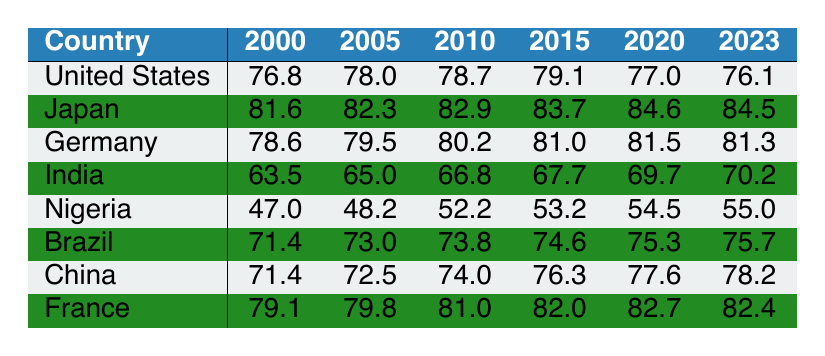What was the life expectancy of Japan in 2010? According to the table, the life expectancy of Japan in 2010 is directly listed as 82.9 years.
Answer: 82.9 Which country had the lowest life expectancy in 2000? Looking at the table, Nigeria had the lowest life expectancy in 2000, recorded at 47.0 years.
Answer: Nigeria What is the difference in life expectancy for China between 2000 and 2023? For China, the life expectancy in 2000 was 71.4 years and in 2023 it is 78.2 years. The difference is 78.2 - 71.4 = 6.8 years.
Answer: 6.8 In which year did Brazil have a life expectancy exceeding 75 years for the first time? By examining the table, Brazil first exceeded a life expectancy of 75 years in 2020, where it is recorded at 75.3 years.
Answer: 2020 Is it true that Germany's life expectancy has decreased from 2015 to 2023? From the table, the life expectancy for Germany in 2015 was 81.0 years, and in 2023 it is 81.3 years, indicating an increase, not a decrease.
Answer: No What is the average life expectancy of India from 2000 to 2023? To calculate the average life expectancy of India from 2000 to 2023, first sum the values: (63.5 + 65.0 + 66.8 + 67.7 + 69.7 + 70.2) = 402.9. Then divide by 6 (the number of years) to get the average: 402.9 / 6 = 67.15 years.
Answer: 67.15 Which country showed the highest life expectancy in 2020? Referring to the table, Japan had the highest life expectancy in 2020 at 84.6 years.
Answer: Japan Did any country among those listed experience a decline in life expectancy from 2015 to 2023? By checking the figures, the United States had a life expectancy of 79.1 in 2015 and dropped to 76.1 in 2023, indicating a decline.
Answer: Yes 